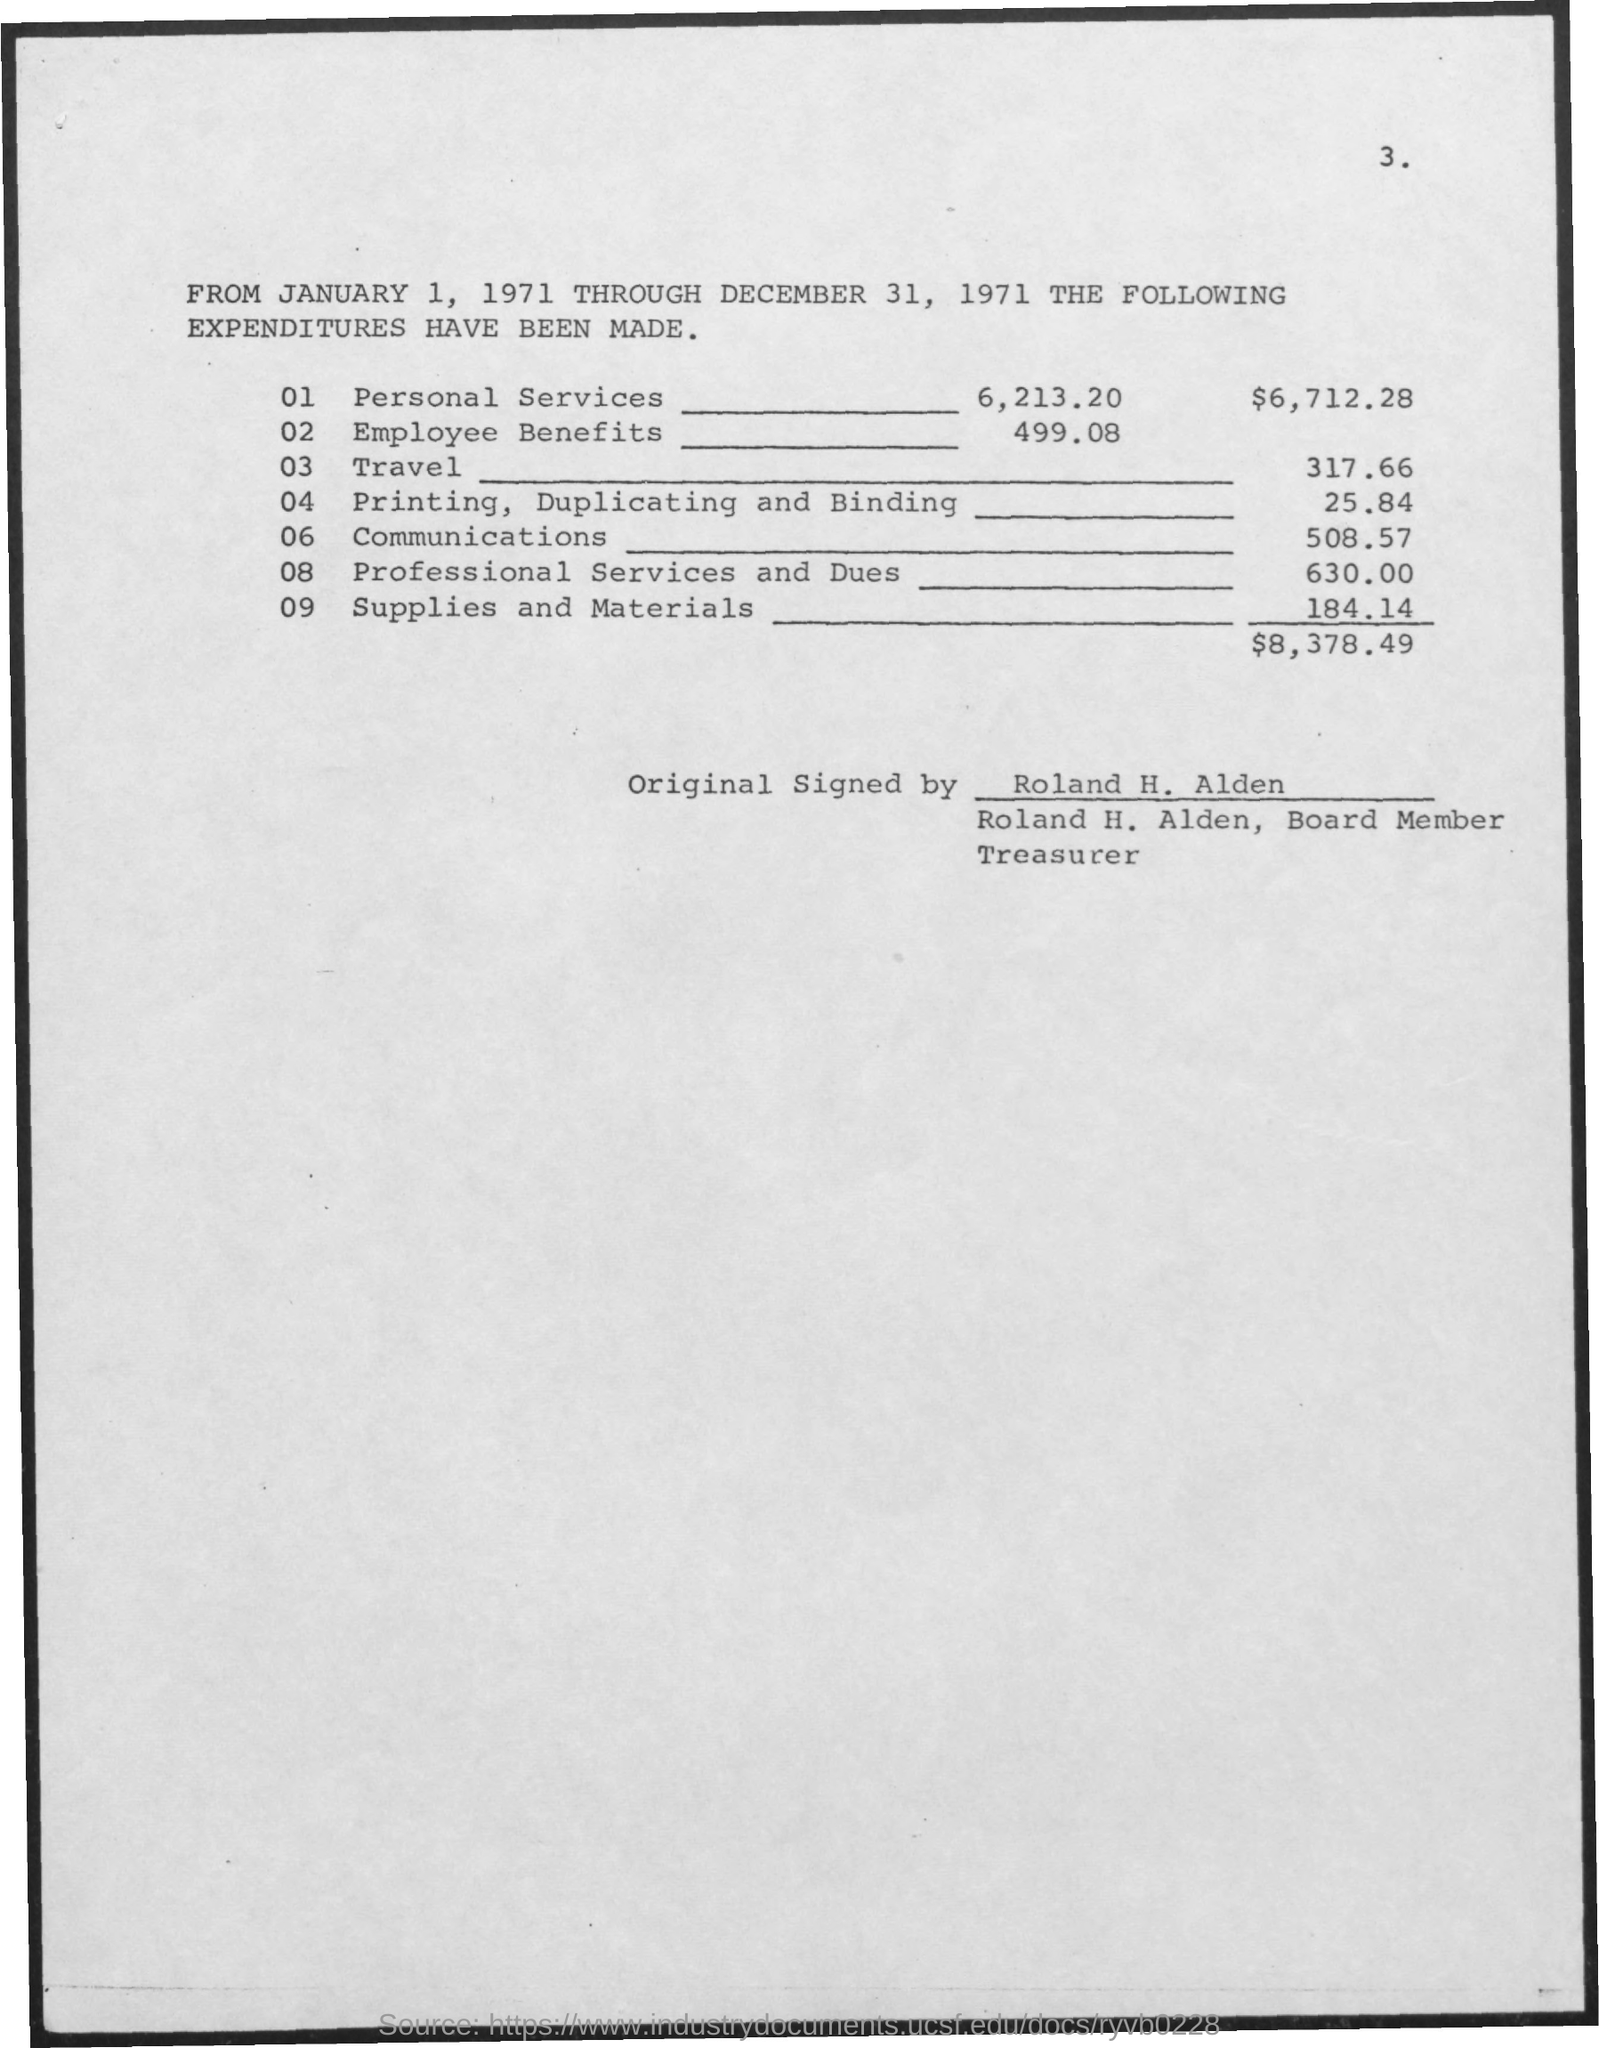What is the Expenditure for Employee Benefits?
Provide a short and direct response. 499.08. What is the Expenditure for Travel?
Ensure brevity in your answer.  317.66. What is the Expenditure for Printing , Duplicating and Binding?
Give a very brief answer. 25.84. What is the Expenditure for Communications?
Give a very brief answer. 508.57. What is the Expenditure for Professional services and dues?
Keep it short and to the point. 630.00. What is the Expenditure for supplies and materials?
Give a very brief answer. 184.14. The expenditures have been made through which dates?
Offer a terse response. January 1, 1971 Through December 31, 1971. 